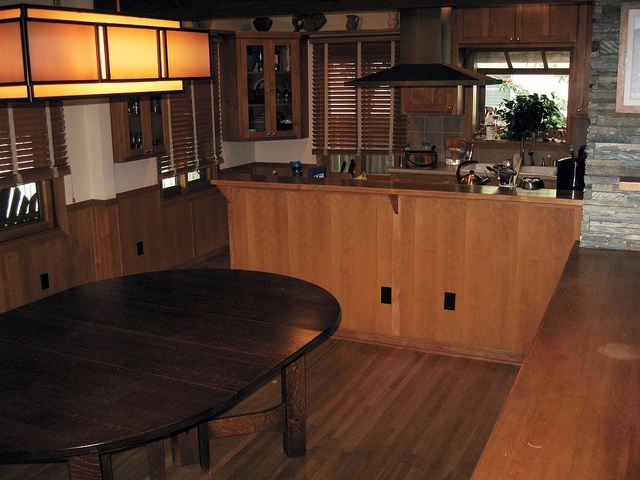Describe the objects in this image and their specific colors. I can see dining table in black, maroon, and brown tones, potted plant in black, ivory, gray, and darkgray tones, sink in black, gray, and darkgray tones, vase in black tones, and vase in black, maroon, and brown tones in this image. 